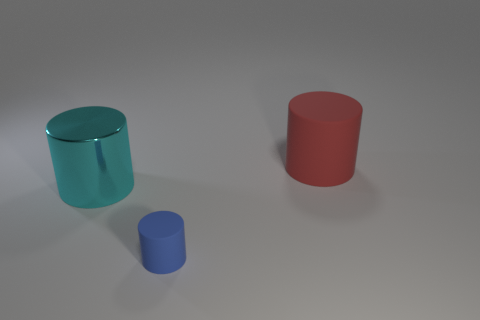What size is the blue thing that is the same material as the big red cylinder?
Your response must be concise. Small. Is there a small rubber cylinder of the same color as the metallic object?
Your answer should be very brief. No. How many things are either large objects that are behind the large cyan metal object or tiny matte cylinders?
Provide a short and direct response. 2. Is the material of the cyan cylinder the same as the thing to the right of the tiny blue matte thing?
Give a very brief answer. No. Are there any green balls that have the same material as the big red cylinder?
Offer a very short reply. No. What number of things are either rubber cylinders that are to the left of the red rubber object or rubber things in front of the large cyan cylinder?
Keep it short and to the point. 1. Is the shape of the big cyan thing the same as the matte thing behind the large cyan metallic object?
Make the answer very short. Yes. What number of other objects are there of the same shape as the big metallic object?
Make the answer very short. 2. How many objects are large cyan matte cubes or big red matte cylinders?
Provide a short and direct response. 1. Is the large rubber cylinder the same color as the tiny rubber cylinder?
Provide a short and direct response. No. 